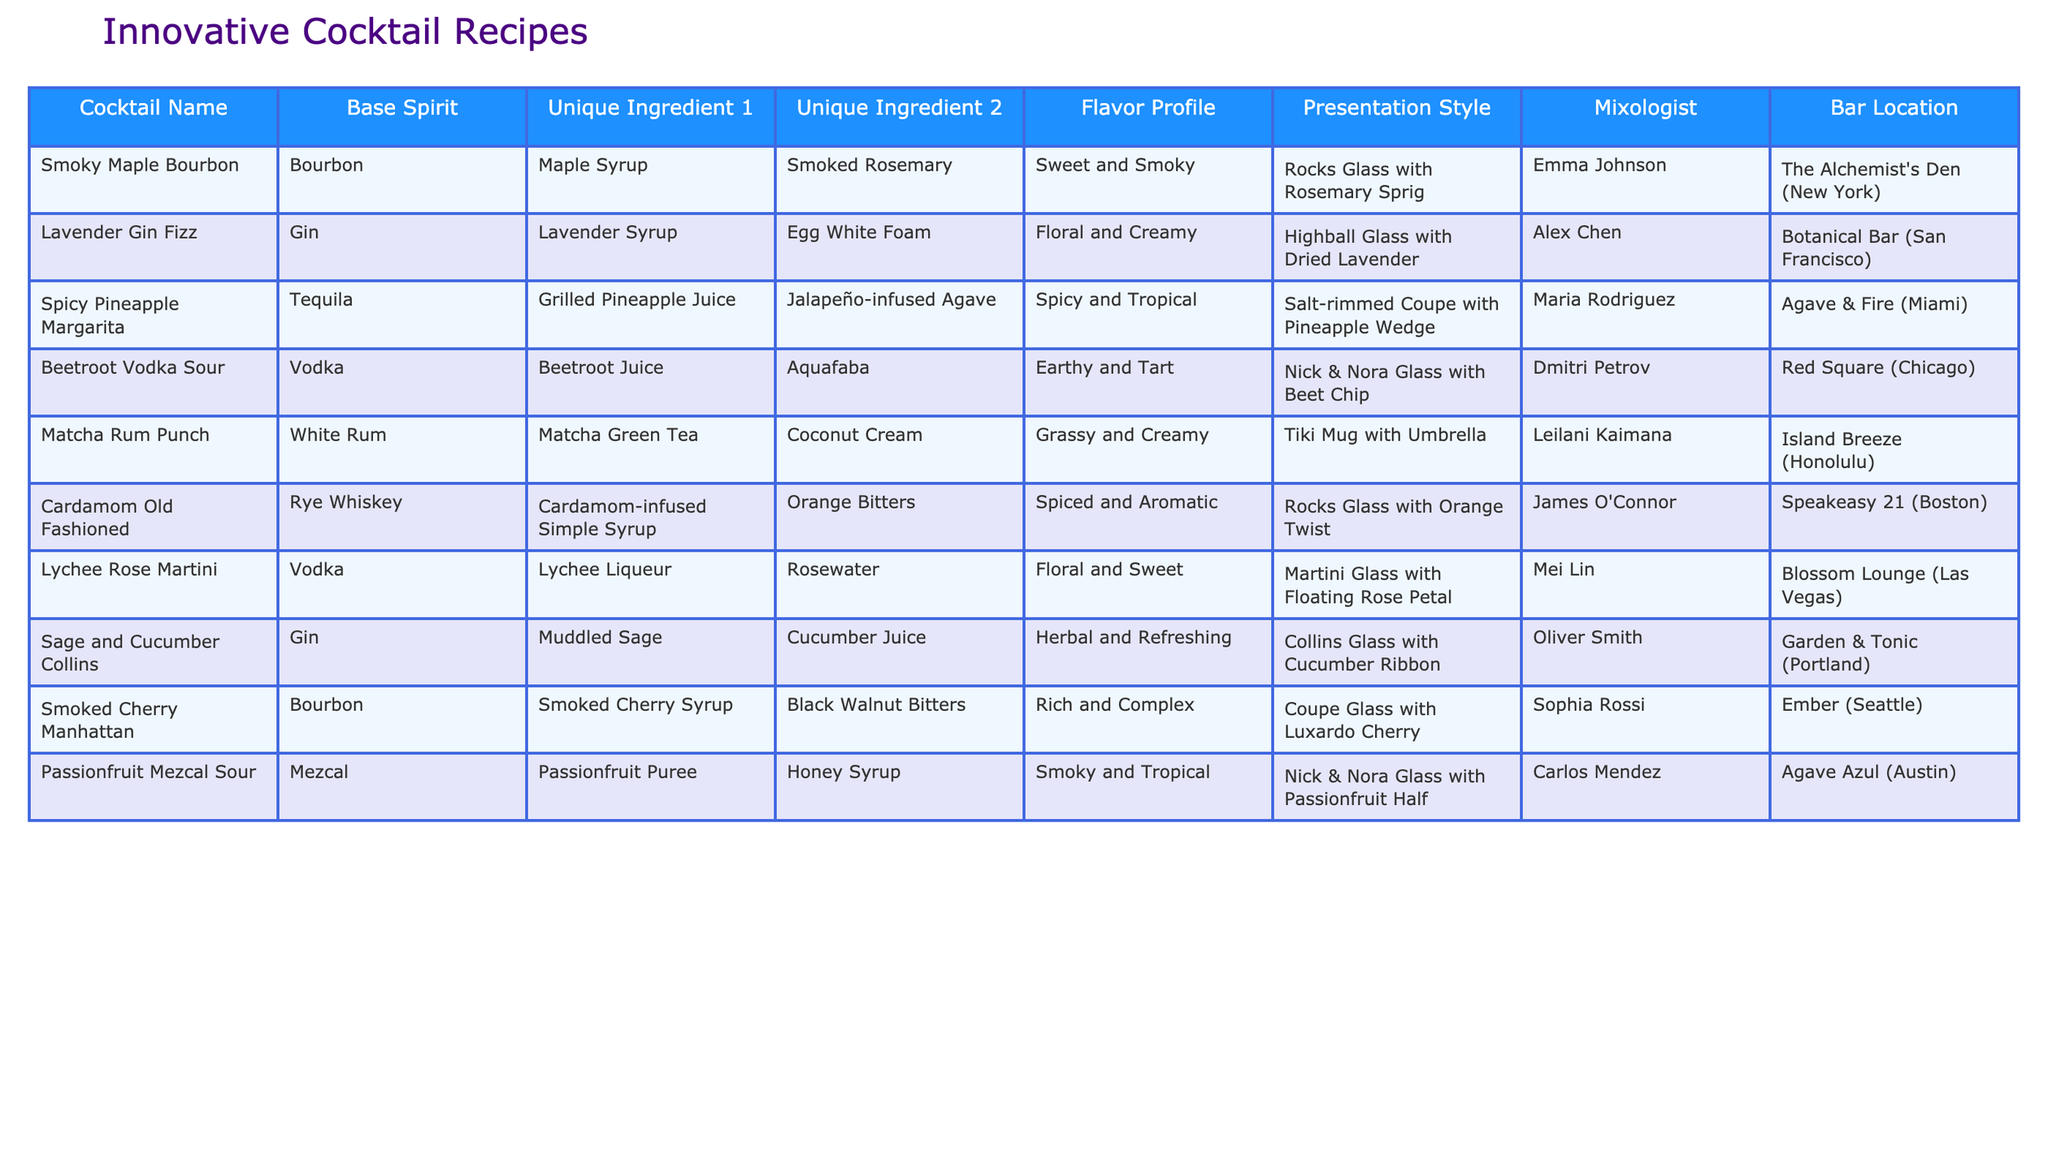What is the base spirit used in the "Lavender Gin Fizz"? The table shows that the "Lavender Gin Fizz" uses Gin as its base spirit.
Answer: Gin Which cocktail has a flavor profile described as "Spicy and Tropical"? Referring to the table, the "Spicy Pineapple Margarita" is described as having a flavor profile of "Spicy and Tropical."
Answer: Spicy Pineapple Margarita Is there a cocktail that combines beetroot juice and vodka? The table indicates that "Beetroot Vodka Sour" combines beetroot juice with vodka; therefore, the statement is true.
Answer: Yes How many cocktails use Bourbon as their base spirit? From the table, there are three cocktails listed with Bourbon as the base spirit: "Smoky Maple Bourbon," "Smoked Cherry Manhattan," and "Passionfruit Mezcal Sour." Therefore, the count is three.
Answer: Three Which mixologist created the "Smoked Cherry Manhattan"? According to the table, Sophia Rossi is the mixologist for the "Smoked Cherry Manhattan."
Answer: Sophia Rossi Which cocktail has both a unique ingredient of maple syrup and a smoky flavor profile? The "Smoky Maple Bourbon" is the only cocktail listed with maple syrup and is described as having a sweet and smoky flavor profile, making it the answer.
Answer: Smoky Maple Bourbon What is the common presentation style for cocktails that include Gin? The table shows two cocktails made with Gin: "Lavender Gin Fizz" presented in a Highball Glass with Dried Lavender, and "Sage and Cucumber Collins" presented in a Collins Glass with Cucumber Ribbon. Hence, there isn't a single common style—they differ.
Answer: They differ Which cocktail features at least one ingredient that is floral? Several cocktails have floral ingredients such as "Lavender Gin Fizz" with Lavender Syrup and "Lychee Rose Martini" with Rosewater. Therefore, the answer includes multiple cocktails.
Answer: Lavender Gin Fizz and Lychee Rose Martini Identify the cocktail that combines coconut cream and matcha green tea. The table lists "Matcha Rum Punch" as combining coconut cream and matcha green tea.
Answer: Matcha Rum Punch Which cocktail, if any, involves muddled sage as an ingredient? According to the table, the "Sage and Cucumber Collins" involves muddled sage as its unique ingredient.
Answer: Sage and Cucumber Collins How many different bars are represented in this list? There are ten cocktails listed, each from a different bar, indicating ten unique bars total in the table.
Answer: Ten 